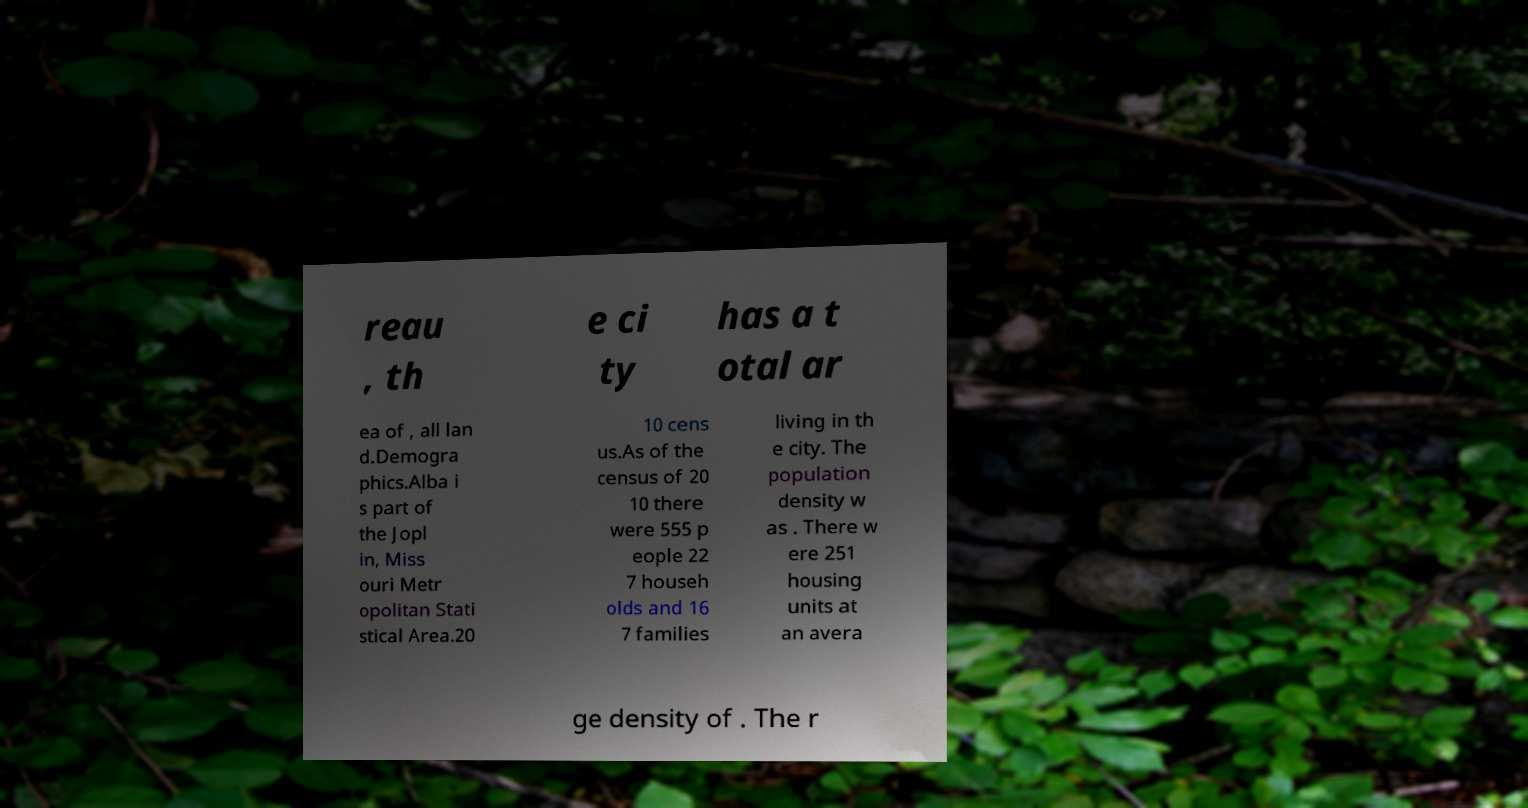Please identify and transcribe the text found in this image. reau , th e ci ty has a t otal ar ea of , all lan d.Demogra phics.Alba i s part of the Jopl in, Miss ouri Metr opolitan Stati stical Area.20 10 cens us.As of the census of 20 10 there were 555 p eople 22 7 househ olds and 16 7 families living in th e city. The population density w as . There w ere 251 housing units at an avera ge density of . The r 